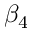<formula> <loc_0><loc_0><loc_500><loc_500>\beta _ { 4 }</formula> 